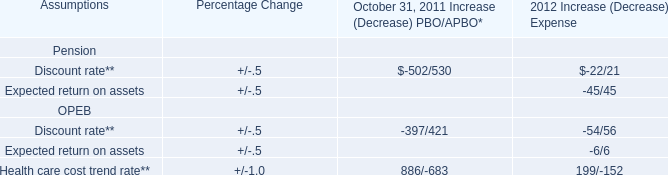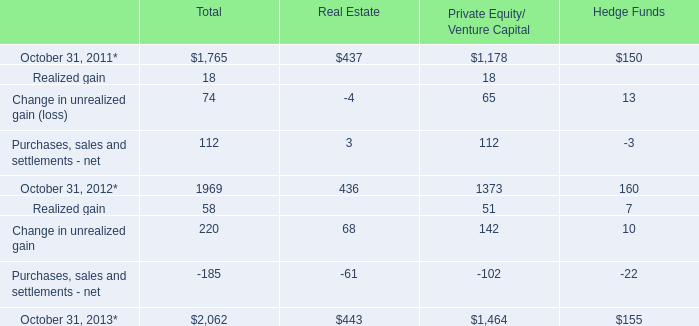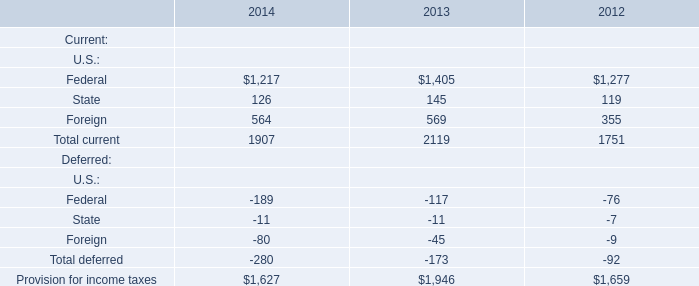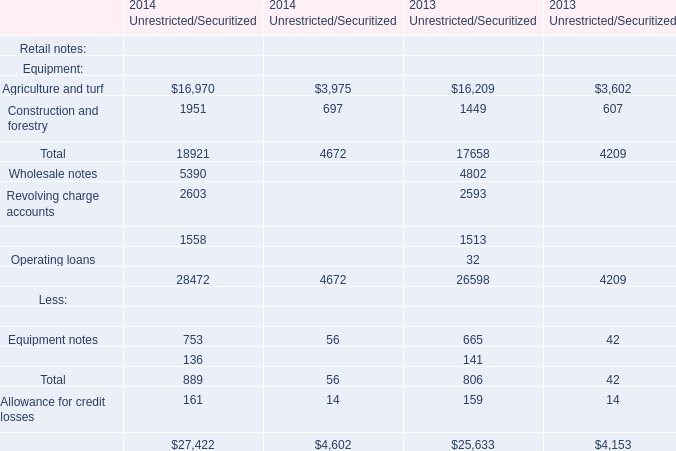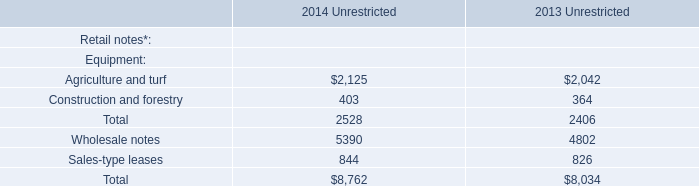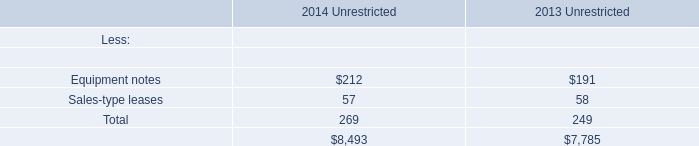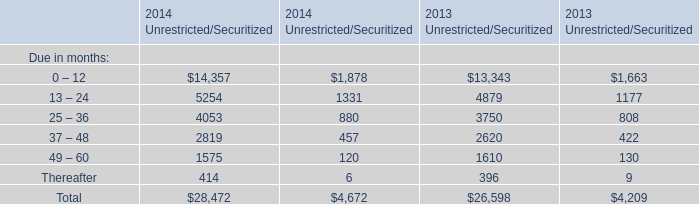In the year/section with the most Sales-type leases, what is the growth rate of Construction and forestry? 
Computations: ((403 - 364) / 364)
Answer: 0.10714. 